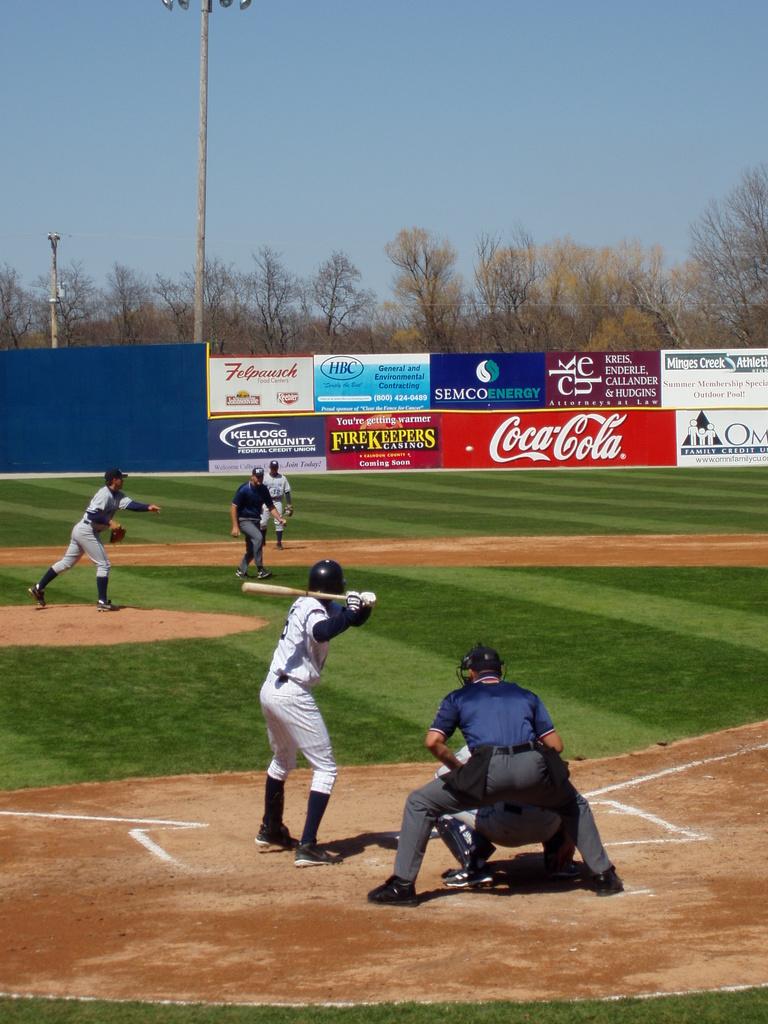What soda brand is advertising on the back wall?
Provide a short and direct response. Coca cola. 